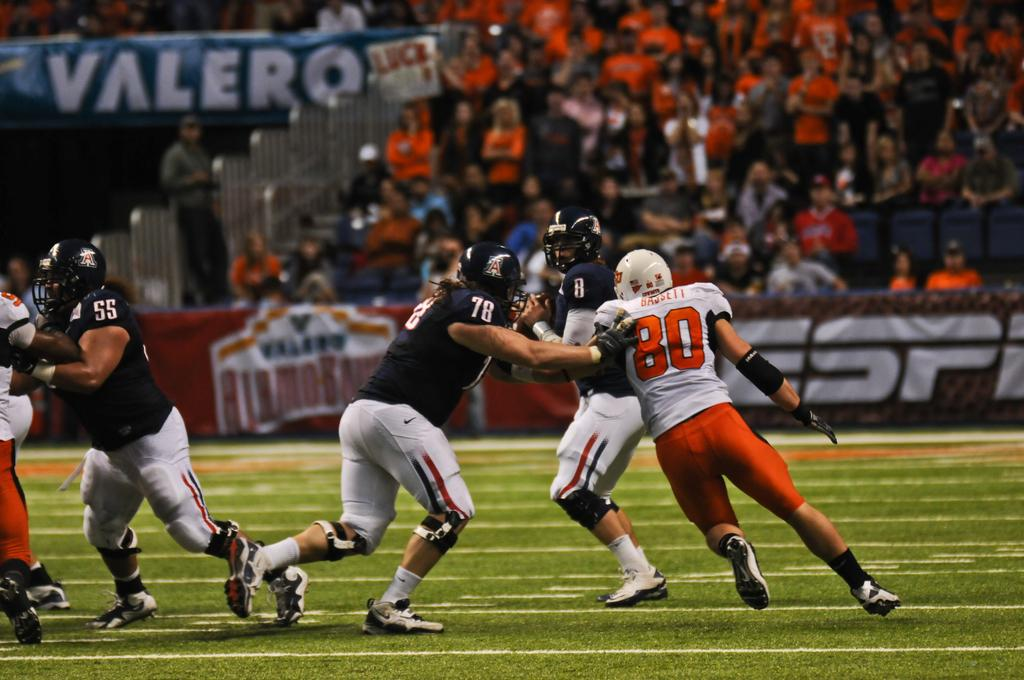What is happening on the ground in the image? There are people on the ground in the image. Can you describe the scene in the background of the image? There is a group of people and advertisement boards in the background of the image. What else can be seen in the background of the image? There are objects visible in the background of the image. What type of brush is being used for the war in the image? There is no war or brush present in the image. Can you make a comparison between the people on the ground and the people in the background in the image? The provided facts do not allow for a comparison between the people on the ground and the people in the background, as no specific details about their actions or characteristics are given. 